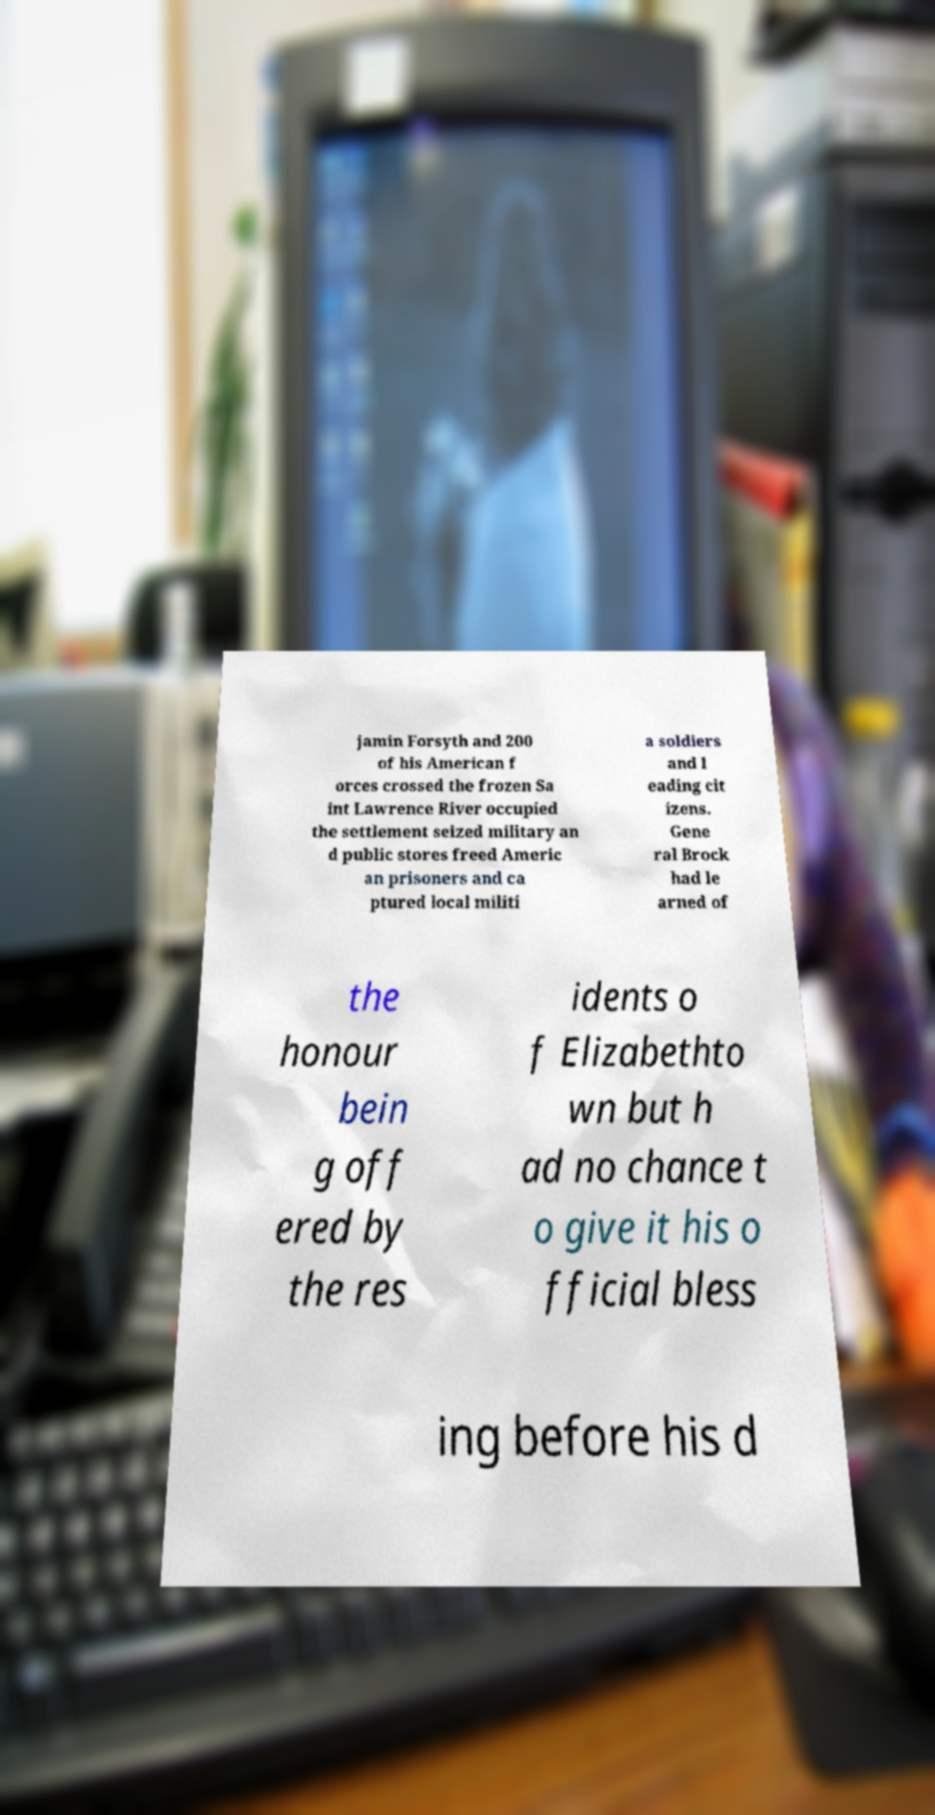Please read and relay the text visible in this image. What does it say? jamin Forsyth and 200 of his American f orces crossed the frozen Sa int Lawrence River occupied the settlement seized military an d public stores freed Americ an prisoners and ca ptured local militi a soldiers and l eading cit izens. Gene ral Brock had le arned of the honour bein g off ered by the res idents o f Elizabethto wn but h ad no chance t o give it his o fficial bless ing before his d 